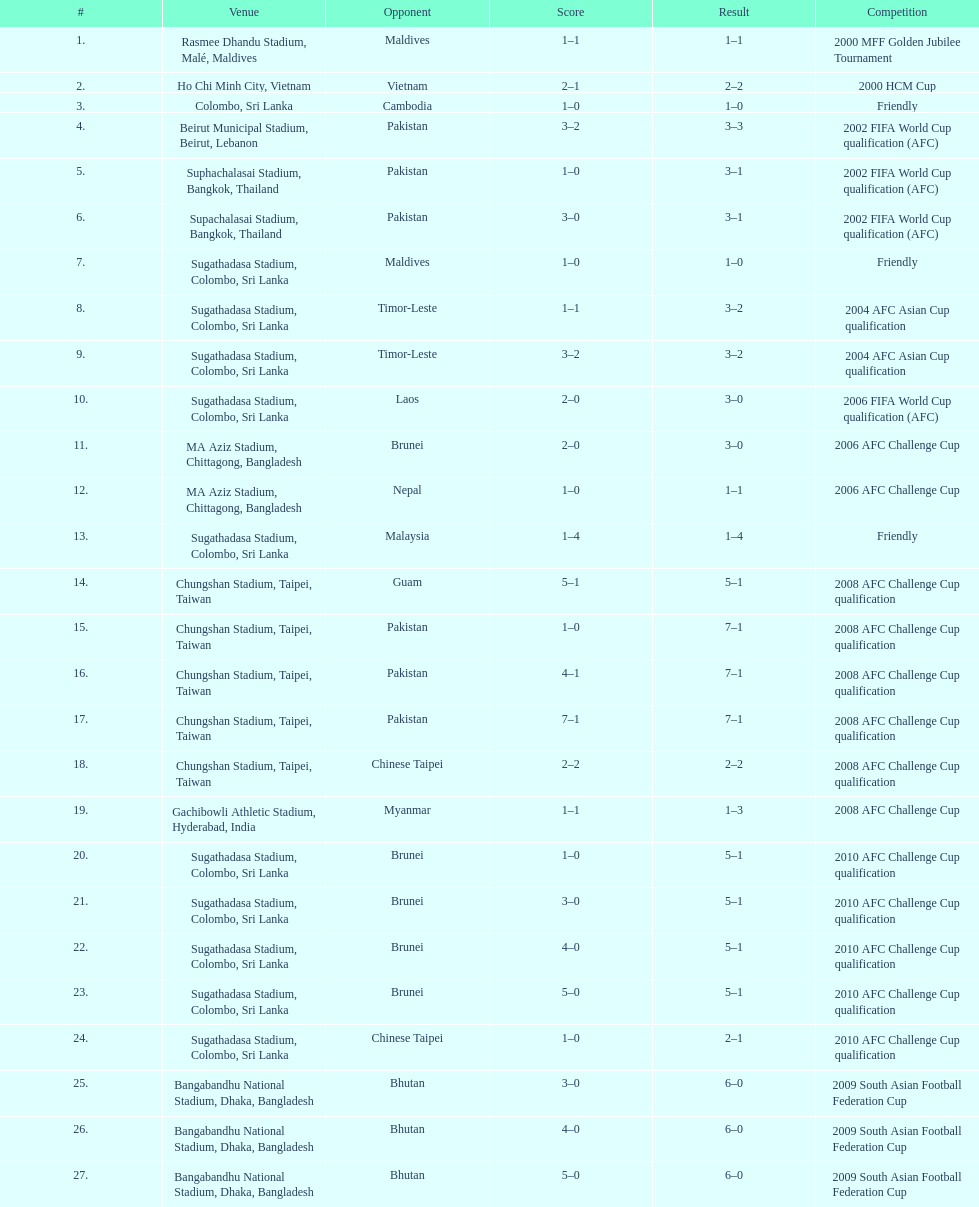In how many contests did sri lanka tally no less than 2 goals? 16. 